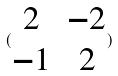Convert formula to latex. <formula><loc_0><loc_0><loc_500><loc_500>( \begin{matrix} 2 & - 2 \\ - 1 & 2 \end{matrix} )</formula> 